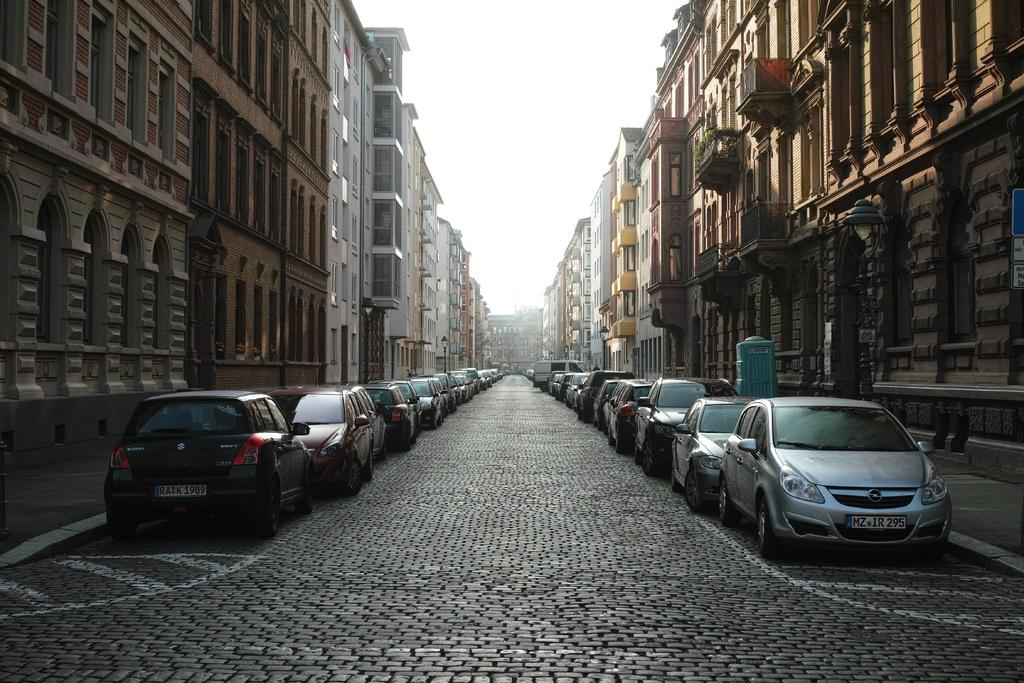What can be seen on the road in the image? There are cars parked on the road. What is located on the left side of the road? There are buildings on the left side of the road. What is located on the right side of the road? There are buildings on the right side of the road. What is the taste of the silver in the image? There is no silver present in the image, so it is not possible to determine its taste. 